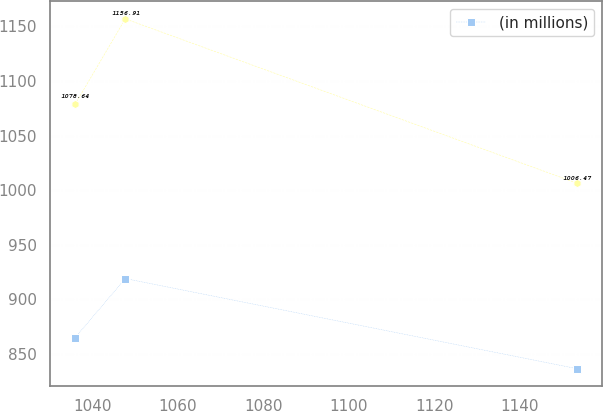Convert chart to OTSL. <chart><loc_0><loc_0><loc_500><loc_500><line_chart><ecel><fcel>Unnamed: 1<fcel>(in millions)<nl><fcel>1036.02<fcel>1078.64<fcel>864.89<nl><fcel>1047.75<fcel>1156.91<fcel>919.02<nl><fcel>1153.29<fcel>1006.47<fcel>836.52<nl></chart> 